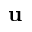<formula> <loc_0><loc_0><loc_500><loc_500>u</formula> 